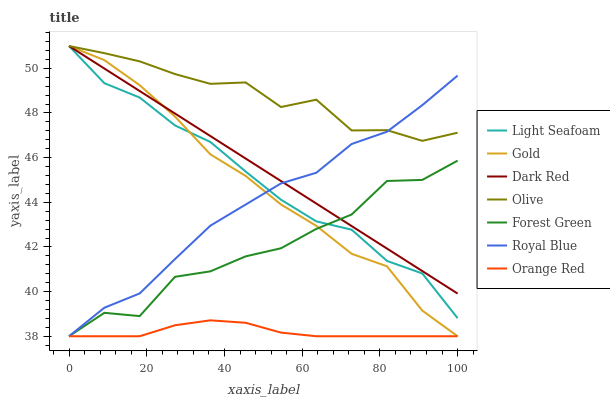Does Dark Red have the minimum area under the curve?
Answer yes or no. No. Does Dark Red have the maximum area under the curve?
Answer yes or no. No. Is Royal Blue the smoothest?
Answer yes or no. No. Is Royal Blue the roughest?
Answer yes or no. No. Does Dark Red have the lowest value?
Answer yes or no. No. Does Royal Blue have the highest value?
Answer yes or no. No. Is Orange Red less than Dark Red?
Answer yes or no. Yes. Is Olive greater than Orange Red?
Answer yes or no. Yes. Does Orange Red intersect Dark Red?
Answer yes or no. No. 